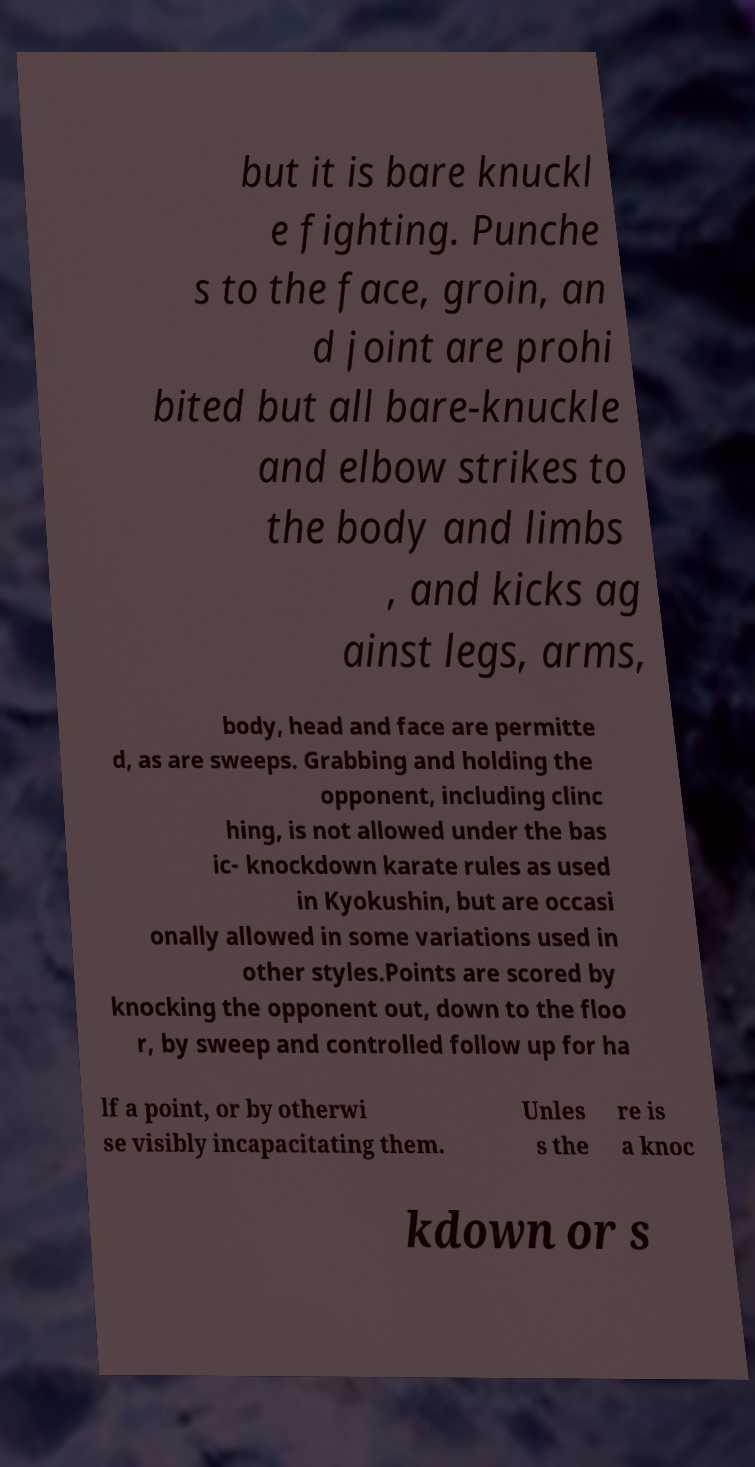I need the written content from this picture converted into text. Can you do that? but it is bare knuckl e fighting. Punche s to the face, groin, an d joint are prohi bited but all bare-knuckle and elbow strikes to the body and limbs , and kicks ag ainst legs, arms, body, head and face are permitte d, as are sweeps. Grabbing and holding the opponent, including clinc hing, is not allowed under the bas ic- knockdown karate rules as used in Kyokushin, but are occasi onally allowed in some variations used in other styles.Points are scored by knocking the opponent out, down to the floo r, by sweep and controlled follow up for ha lf a point, or by otherwi se visibly incapacitating them. Unles s the re is a knoc kdown or s 